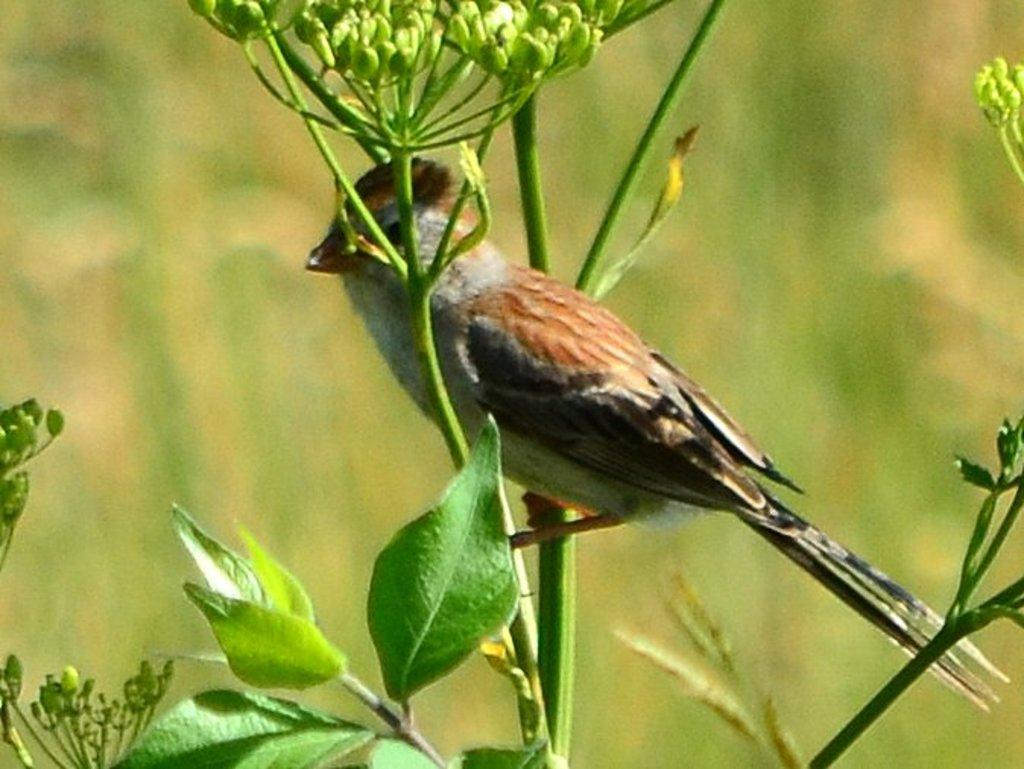What type of animal is in the image? There is a bird in the image. Where is the bird located in the image? The bird is standing on the stem of a plant. What can be observed about the plant in the image? The plant has leaves and flower buds. What type of treatment is the bird receiving in the image? There is no indication in the image that the bird is receiving any treatment. Is there any eggnog present in the image? There is no mention of eggnog in the image. 